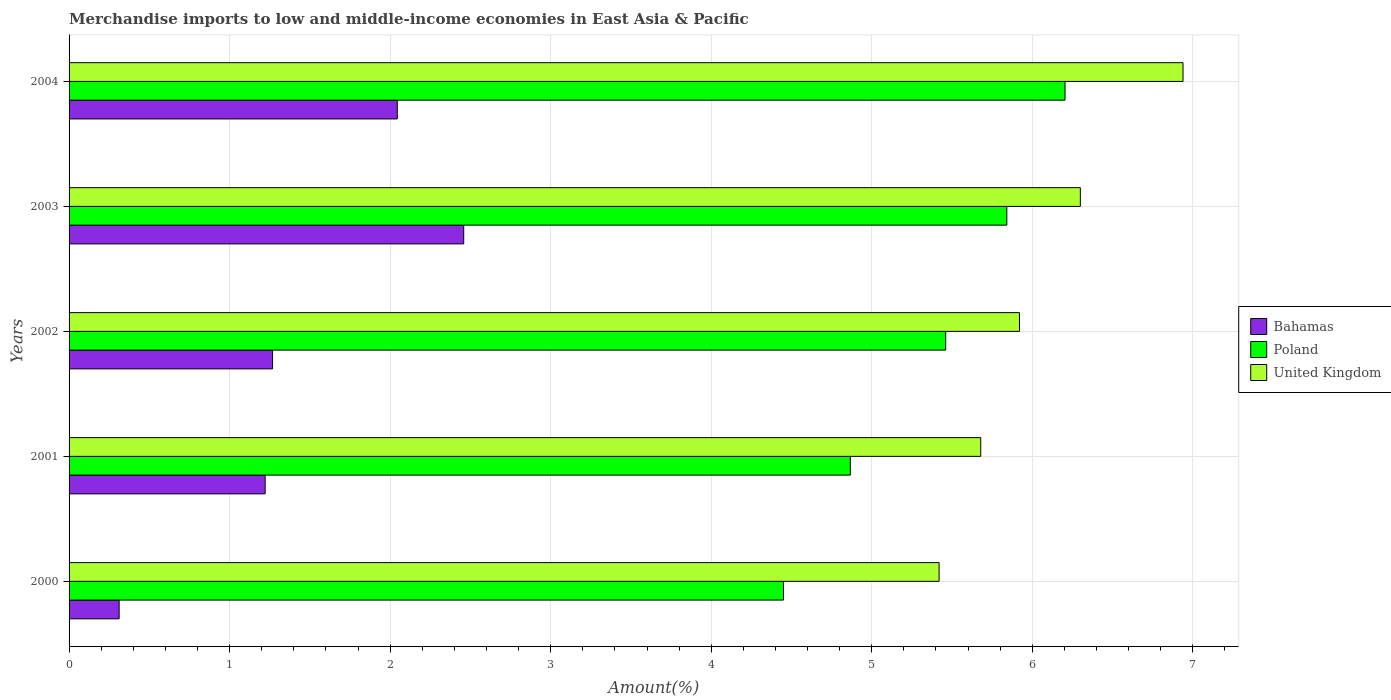Are the number of bars per tick equal to the number of legend labels?
Your answer should be very brief. Yes. What is the label of the 1st group of bars from the top?
Offer a terse response. 2004. What is the percentage of amount earned from merchandise imports in Bahamas in 2004?
Your answer should be compact. 2.04. Across all years, what is the maximum percentage of amount earned from merchandise imports in United Kingdom?
Give a very brief answer. 6.94. Across all years, what is the minimum percentage of amount earned from merchandise imports in United Kingdom?
Your answer should be compact. 5.42. In which year was the percentage of amount earned from merchandise imports in Bahamas maximum?
Provide a succinct answer. 2003. What is the total percentage of amount earned from merchandise imports in Poland in the graph?
Provide a short and direct response. 26.82. What is the difference between the percentage of amount earned from merchandise imports in Bahamas in 2000 and that in 2004?
Provide a short and direct response. -1.73. What is the difference between the percentage of amount earned from merchandise imports in United Kingdom in 2001 and the percentage of amount earned from merchandise imports in Bahamas in 2003?
Provide a succinct answer. 3.22. What is the average percentage of amount earned from merchandise imports in Bahamas per year?
Make the answer very short. 1.46. In the year 2001, what is the difference between the percentage of amount earned from merchandise imports in Bahamas and percentage of amount earned from merchandise imports in Poland?
Give a very brief answer. -3.65. What is the ratio of the percentage of amount earned from merchandise imports in Poland in 2003 to that in 2004?
Provide a short and direct response. 0.94. Is the percentage of amount earned from merchandise imports in Bahamas in 2002 less than that in 2003?
Offer a terse response. Yes. Is the difference between the percentage of amount earned from merchandise imports in Bahamas in 2002 and 2003 greater than the difference between the percentage of amount earned from merchandise imports in Poland in 2002 and 2003?
Give a very brief answer. No. What is the difference between the highest and the second highest percentage of amount earned from merchandise imports in United Kingdom?
Offer a terse response. 0.64. What is the difference between the highest and the lowest percentage of amount earned from merchandise imports in United Kingdom?
Your response must be concise. 1.52. In how many years, is the percentage of amount earned from merchandise imports in Bahamas greater than the average percentage of amount earned from merchandise imports in Bahamas taken over all years?
Make the answer very short. 2. What does the 2nd bar from the top in 2001 represents?
Give a very brief answer. Poland. What does the 1st bar from the bottom in 2004 represents?
Offer a very short reply. Bahamas. Is it the case that in every year, the sum of the percentage of amount earned from merchandise imports in United Kingdom and percentage of amount earned from merchandise imports in Poland is greater than the percentage of amount earned from merchandise imports in Bahamas?
Give a very brief answer. Yes. What is the difference between two consecutive major ticks on the X-axis?
Your response must be concise. 1. Does the graph contain any zero values?
Your answer should be compact. No. Does the graph contain grids?
Offer a very short reply. Yes. How many legend labels are there?
Keep it short and to the point. 3. What is the title of the graph?
Provide a short and direct response. Merchandise imports to low and middle-income economies in East Asia & Pacific. What is the label or title of the X-axis?
Give a very brief answer. Amount(%). What is the Amount(%) of Bahamas in 2000?
Provide a succinct answer. 0.31. What is the Amount(%) of Poland in 2000?
Your answer should be very brief. 4.45. What is the Amount(%) in United Kingdom in 2000?
Provide a short and direct response. 5.42. What is the Amount(%) of Bahamas in 2001?
Provide a succinct answer. 1.22. What is the Amount(%) of Poland in 2001?
Your answer should be very brief. 4.87. What is the Amount(%) of United Kingdom in 2001?
Your answer should be compact. 5.68. What is the Amount(%) of Bahamas in 2002?
Offer a terse response. 1.27. What is the Amount(%) of Poland in 2002?
Ensure brevity in your answer.  5.46. What is the Amount(%) of United Kingdom in 2002?
Your answer should be compact. 5.92. What is the Amount(%) in Bahamas in 2003?
Give a very brief answer. 2.46. What is the Amount(%) of Poland in 2003?
Offer a very short reply. 5.84. What is the Amount(%) in United Kingdom in 2003?
Offer a very short reply. 6.3. What is the Amount(%) in Bahamas in 2004?
Provide a succinct answer. 2.04. What is the Amount(%) of Poland in 2004?
Ensure brevity in your answer.  6.2. What is the Amount(%) of United Kingdom in 2004?
Ensure brevity in your answer.  6.94. Across all years, what is the maximum Amount(%) of Bahamas?
Provide a succinct answer. 2.46. Across all years, what is the maximum Amount(%) in Poland?
Your response must be concise. 6.2. Across all years, what is the maximum Amount(%) in United Kingdom?
Make the answer very short. 6.94. Across all years, what is the minimum Amount(%) of Bahamas?
Offer a terse response. 0.31. Across all years, what is the minimum Amount(%) in Poland?
Keep it short and to the point. 4.45. Across all years, what is the minimum Amount(%) of United Kingdom?
Offer a very short reply. 5.42. What is the total Amount(%) in Bahamas in the graph?
Keep it short and to the point. 7.3. What is the total Amount(%) in Poland in the graph?
Ensure brevity in your answer.  26.82. What is the total Amount(%) of United Kingdom in the graph?
Offer a terse response. 30.26. What is the difference between the Amount(%) of Bahamas in 2000 and that in 2001?
Make the answer very short. -0.91. What is the difference between the Amount(%) of Poland in 2000 and that in 2001?
Your answer should be compact. -0.42. What is the difference between the Amount(%) in United Kingdom in 2000 and that in 2001?
Your answer should be compact. -0.26. What is the difference between the Amount(%) of Bahamas in 2000 and that in 2002?
Make the answer very short. -0.96. What is the difference between the Amount(%) in Poland in 2000 and that in 2002?
Offer a terse response. -1.01. What is the difference between the Amount(%) in United Kingdom in 2000 and that in 2002?
Provide a succinct answer. -0.5. What is the difference between the Amount(%) in Bahamas in 2000 and that in 2003?
Give a very brief answer. -2.15. What is the difference between the Amount(%) of Poland in 2000 and that in 2003?
Your answer should be very brief. -1.39. What is the difference between the Amount(%) in United Kingdom in 2000 and that in 2003?
Give a very brief answer. -0.88. What is the difference between the Amount(%) of Bahamas in 2000 and that in 2004?
Give a very brief answer. -1.73. What is the difference between the Amount(%) in Poland in 2000 and that in 2004?
Your answer should be very brief. -1.75. What is the difference between the Amount(%) of United Kingdom in 2000 and that in 2004?
Provide a short and direct response. -1.52. What is the difference between the Amount(%) in Bahamas in 2001 and that in 2002?
Make the answer very short. -0.05. What is the difference between the Amount(%) of Poland in 2001 and that in 2002?
Provide a succinct answer. -0.59. What is the difference between the Amount(%) in United Kingdom in 2001 and that in 2002?
Offer a terse response. -0.24. What is the difference between the Amount(%) in Bahamas in 2001 and that in 2003?
Ensure brevity in your answer.  -1.24. What is the difference between the Amount(%) of Poland in 2001 and that in 2003?
Ensure brevity in your answer.  -0.97. What is the difference between the Amount(%) of United Kingdom in 2001 and that in 2003?
Your response must be concise. -0.62. What is the difference between the Amount(%) of Bahamas in 2001 and that in 2004?
Make the answer very short. -0.82. What is the difference between the Amount(%) in Poland in 2001 and that in 2004?
Offer a terse response. -1.34. What is the difference between the Amount(%) of United Kingdom in 2001 and that in 2004?
Give a very brief answer. -1.26. What is the difference between the Amount(%) of Bahamas in 2002 and that in 2003?
Offer a very short reply. -1.19. What is the difference between the Amount(%) in Poland in 2002 and that in 2003?
Ensure brevity in your answer.  -0.38. What is the difference between the Amount(%) in United Kingdom in 2002 and that in 2003?
Offer a terse response. -0.38. What is the difference between the Amount(%) of Bahamas in 2002 and that in 2004?
Your answer should be compact. -0.78. What is the difference between the Amount(%) in Poland in 2002 and that in 2004?
Provide a succinct answer. -0.74. What is the difference between the Amount(%) in United Kingdom in 2002 and that in 2004?
Your response must be concise. -1.02. What is the difference between the Amount(%) of Bahamas in 2003 and that in 2004?
Keep it short and to the point. 0.41. What is the difference between the Amount(%) of Poland in 2003 and that in 2004?
Your answer should be compact. -0.36. What is the difference between the Amount(%) of United Kingdom in 2003 and that in 2004?
Provide a succinct answer. -0.64. What is the difference between the Amount(%) of Bahamas in 2000 and the Amount(%) of Poland in 2001?
Give a very brief answer. -4.55. What is the difference between the Amount(%) of Bahamas in 2000 and the Amount(%) of United Kingdom in 2001?
Make the answer very short. -5.37. What is the difference between the Amount(%) in Poland in 2000 and the Amount(%) in United Kingdom in 2001?
Provide a succinct answer. -1.23. What is the difference between the Amount(%) in Bahamas in 2000 and the Amount(%) in Poland in 2002?
Provide a short and direct response. -5.15. What is the difference between the Amount(%) in Bahamas in 2000 and the Amount(%) in United Kingdom in 2002?
Offer a very short reply. -5.61. What is the difference between the Amount(%) of Poland in 2000 and the Amount(%) of United Kingdom in 2002?
Your response must be concise. -1.47. What is the difference between the Amount(%) in Bahamas in 2000 and the Amount(%) in Poland in 2003?
Make the answer very short. -5.53. What is the difference between the Amount(%) of Bahamas in 2000 and the Amount(%) of United Kingdom in 2003?
Give a very brief answer. -5.99. What is the difference between the Amount(%) in Poland in 2000 and the Amount(%) in United Kingdom in 2003?
Give a very brief answer. -1.85. What is the difference between the Amount(%) in Bahamas in 2000 and the Amount(%) in Poland in 2004?
Provide a succinct answer. -5.89. What is the difference between the Amount(%) in Bahamas in 2000 and the Amount(%) in United Kingdom in 2004?
Your response must be concise. -6.63. What is the difference between the Amount(%) of Poland in 2000 and the Amount(%) of United Kingdom in 2004?
Your response must be concise. -2.49. What is the difference between the Amount(%) of Bahamas in 2001 and the Amount(%) of Poland in 2002?
Your answer should be compact. -4.24. What is the difference between the Amount(%) of Bahamas in 2001 and the Amount(%) of United Kingdom in 2002?
Ensure brevity in your answer.  -4.7. What is the difference between the Amount(%) in Poland in 2001 and the Amount(%) in United Kingdom in 2002?
Give a very brief answer. -1.05. What is the difference between the Amount(%) in Bahamas in 2001 and the Amount(%) in Poland in 2003?
Provide a short and direct response. -4.62. What is the difference between the Amount(%) in Bahamas in 2001 and the Amount(%) in United Kingdom in 2003?
Your response must be concise. -5.08. What is the difference between the Amount(%) of Poland in 2001 and the Amount(%) of United Kingdom in 2003?
Your answer should be compact. -1.43. What is the difference between the Amount(%) in Bahamas in 2001 and the Amount(%) in Poland in 2004?
Your response must be concise. -4.98. What is the difference between the Amount(%) in Bahamas in 2001 and the Amount(%) in United Kingdom in 2004?
Keep it short and to the point. -5.72. What is the difference between the Amount(%) of Poland in 2001 and the Amount(%) of United Kingdom in 2004?
Provide a succinct answer. -2.07. What is the difference between the Amount(%) of Bahamas in 2002 and the Amount(%) of Poland in 2003?
Offer a very short reply. -4.57. What is the difference between the Amount(%) of Bahamas in 2002 and the Amount(%) of United Kingdom in 2003?
Your response must be concise. -5.03. What is the difference between the Amount(%) of Poland in 2002 and the Amount(%) of United Kingdom in 2003?
Offer a terse response. -0.84. What is the difference between the Amount(%) in Bahamas in 2002 and the Amount(%) in Poland in 2004?
Keep it short and to the point. -4.94. What is the difference between the Amount(%) in Bahamas in 2002 and the Amount(%) in United Kingdom in 2004?
Ensure brevity in your answer.  -5.67. What is the difference between the Amount(%) in Poland in 2002 and the Amount(%) in United Kingdom in 2004?
Your answer should be very brief. -1.48. What is the difference between the Amount(%) of Bahamas in 2003 and the Amount(%) of Poland in 2004?
Your answer should be compact. -3.75. What is the difference between the Amount(%) of Bahamas in 2003 and the Amount(%) of United Kingdom in 2004?
Your response must be concise. -4.48. What is the difference between the Amount(%) in Poland in 2003 and the Amount(%) in United Kingdom in 2004?
Keep it short and to the point. -1.1. What is the average Amount(%) in Bahamas per year?
Your response must be concise. 1.46. What is the average Amount(%) of Poland per year?
Make the answer very short. 5.36. What is the average Amount(%) in United Kingdom per year?
Provide a succinct answer. 6.05. In the year 2000, what is the difference between the Amount(%) in Bahamas and Amount(%) in Poland?
Your answer should be compact. -4.14. In the year 2000, what is the difference between the Amount(%) of Bahamas and Amount(%) of United Kingdom?
Keep it short and to the point. -5.11. In the year 2000, what is the difference between the Amount(%) in Poland and Amount(%) in United Kingdom?
Your answer should be very brief. -0.97. In the year 2001, what is the difference between the Amount(%) in Bahamas and Amount(%) in Poland?
Your answer should be very brief. -3.65. In the year 2001, what is the difference between the Amount(%) in Bahamas and Amount(%) in United Kingdom?
Your answer should be compact. -4.46. In the year 2001, what is the difference between the Amount(%) of Poland and Amount(%) of United Kingdom?
Give a very brief answer. -0.81. In the year 2002, what is the difference between the Amount(%) of Bahamas and Amount(%) of Poland?
Your answer should be compact. -4.19. In the year 2002, what is the difference between the Amount(%) in Bahamas and Amount(%) in United Kingdom?
Provide a succinct answer. -4.65. In the year 2002, what is the difference between the Amount(%) in Poland and Amount(%) in United Kingdom?
Offer a terse response. -0.46. In the year 2003, what is the difference between the Amount(%) of Bahamas and Amount(%) of Poland?
Make the answer very short. -3.38. In the year 2003, what is the difference between the Amount(%) of Bahamas and Amount(%) of United Kingdom?
Your answer should be compact. -3.84. In the year 2003, what is the difference between the Amount(%) of Poland and Amount(%) of United Kingdom?
Your response must be concise. -0.46. In the year 2004, what is the difference between the Amount(%) of Bahamas and Amount(%) of Poland?
Give a very brief answer. -4.16. In the year 2004, what is the difference between the Amount(%) in Bahamas and Amount(%) in United Kingdom?
Keep it short and to the point. -4.89. In the year 2004, what is the difference between the Amount(%) of Poland and Amount(%) of United Kingdom?
Your response must be concise. -0.73. What is the ratio of the Amount(%) in Bahamas in 2000 to that in 2001?
Give a very brief answer. 0.26. What is the ratio of the Amount(%) of Poland in 2000 to that in 2001?
Your answer should be compact. 0.91. What is the ratio of the Amount(%) of United Kingdom in 2000 to that in 2001?
Your answer should be very brief. 0.95. What is the ratio of the Amount(%) in Bahamas in 2000 to that in 2002?
Offer a terse response. 0.25. What is the ratio of the Amount(%) of Poland in 2000 to that in 2002?
Ensure brevity in your answer.  0.81. What is the ratio of the Amount(%) in United Kingdom in 2000 to that in 2002?
Your response must be concise. 0.92. What is the ratio of the Amount(%) in Bahamas in 2000 to that in 2003?
Keep it short and to the point. 0.13. What is the ratio of the Amount(%) in Poland in 2000 to that in 2003?
Ensure brevity in your answer.  0.76. What is the ratio of the Amount(%) of United Kingdom in 2000 to that in 2003?
Your answer should be compact. 0.86. What is the ratio of the Amount(%) of Bahamas in 2000 to that in 2004?
Provide a succinct answer. 0.15. What is the ratio of the Amount(%) in Poland in 2000 to that in 2004?
Your answer should be very brief. 0.72. What is the ratio of the Amount(%) in United Kingdom in 2000 to that in 2004?
Offer a terse response. 0.78. What is the ratio of the Amount(%) in Bahamas in 2001 to that in 2002?
Provide a succinct answer. 0.96. What is the ratio of the Amount(%) of Poland in 2001 to that in 2002?
Provide a succinct answer. 0.89. What is the ratio of the Amount(%) of United Kingdom in 2001 to that in 2002?
Your answer should be very brief. 0.96. What is the ratio of the Amount(%) in Bahamas in 2001 to that in 2003?
Your answer should be very brief. 0.5. What is the ratio of the Amount(%) in Poland in 2001 to that in 2003?
Your answer should be compact. 0.83. What is the ratio of the Amount(%) in United Kingdom in 2001 to that in 2003?
Provide a short and direct response. 0.9. What is the ratio of the Amount(%) in Bahamas in 2001 to that in 2004?
Ensure brevity in your answer.  0.6. What is the ratio of the Amount(%) of Poland in 2001 to that in 2004?
Provide a succinct answer. 0.78. What is the ratio of the Amount(%) of United Kingdom in 2001 to that in 2004?
Provide a short and direct response. 0.82. What is the ratio of the Amount(%) in Bahamas in 2002 to that in 2003?
Make the answer very short. 0.52. What is the ratio of the Amount(%) of Poland in 2002 to that in 2003?
Offer a terse response. 0.93. What is the ratio of the Amount(%) in United Kingdom in 2002 to that in 2003?
Offer a terse response. 0.94. What is the ratio of the Amount(%) in Bahamas in 2002 to that in 2004?
Offer a terse response. 0.62. What is the ratio of the Amount(%) in Poland in 2002 to that in 2004?
Ensure brevity in your answer.  0.88. What is the ratio of the Amount(%) of United Kingdom in 2002 to that in 2004?
Give a very brief answer. 0.85. What is the ratio of the Amount(%) of Bahamas in 2003 to that in 2004?
Offer a very short reply. 1.2. What is the ratio of the Amount(%) of Poland in 2003 to that in 2004?
Ensure brevity in your answer.  0.94. What is the ratio of the Amount(%) of United Kingdom in 2003 to that in 2004?
Provide a succinct answer. 0.91. What is the difference between the highest and the second highest Amount(%) in Bahamas?
Your response must be concise. 0.41. What is the difference between the highest and the second highest Amount(%) of Poland?
Keep it short and to the point. 0.36. What is the difference between the highest and the second highest Amount(%) in United Kingdom?
Ensure brevity in your answer.  0.64. What is the difference between the highest and the lowest Amount(%) in Bahamas?
Your answer should be very brief. 2.15. What is the difference between the highest and the lowest Amount(%) of Poland?
Your response must be concise. 1.75. What is the difference between the highest and the lowest Amount(%) in United Kingdom?
Make the answer very short. 1.52. 